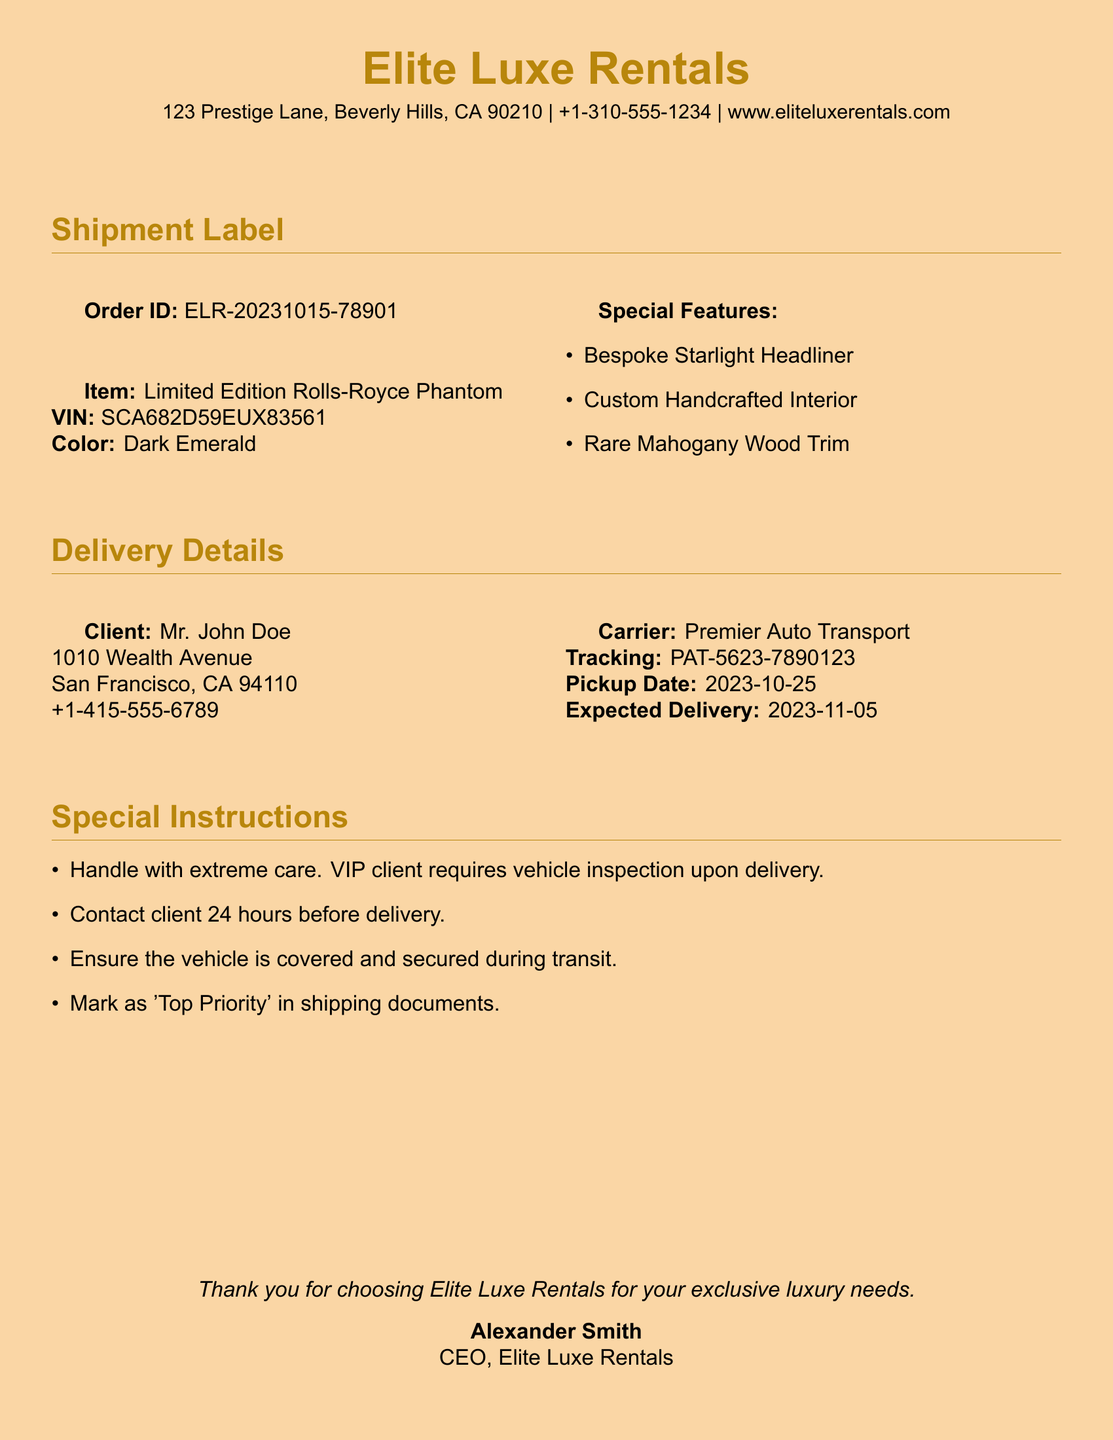What is the color of the car? The document specifies that the color of the car is Dark Emerald.
Answer: Dark Emerald What is the order ID? The document displays the order ID, which is ELR-20231015-78901.
Answer: ELR-20231015-78901 Who is the client? The document lists Mr. John Doe as the client for this shipment.
Answer: Mr. John Doe What is the VIN of the vehicle? The document provides the VIN as SCA682D59EUX83561.
Answer: SCA682D59EUX83561 When is the expected delivery date? The document states that the expected delivery date is 2023-11-05.
Answer: 2023-11-05 Which carrier is handling the shipment? The document identifies Premier Auto Transport as the carrier for the shipment.
Answer: Premier Auto Transport What special feature is mentioned first? The document lists the Bespoke Starlight Headliner as the first special feature.
Answer: Bespoke Starlight Headliner How many special instructions are provided? The document includes four special instructions related to the shipment.
Answer: Four What is the pickup date? The document indicates that the pickup date for the vehicle is 2023-10-25.
Answer: 2023-10-25 